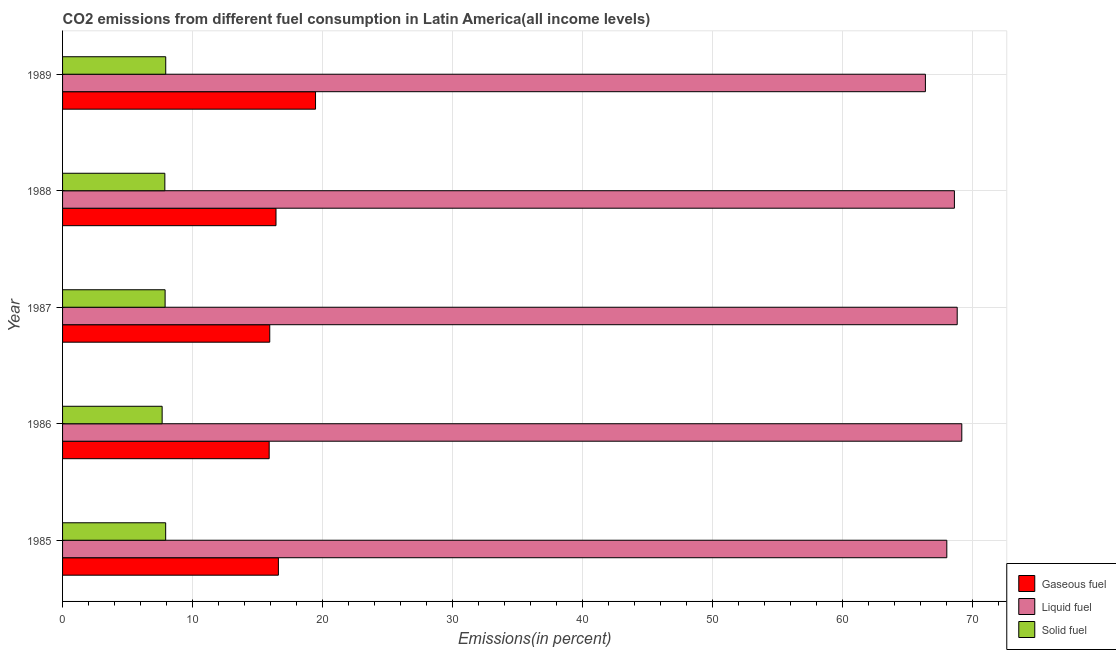How many different coloured bars are there?
Offer a very short reply. 3. Are the number of bars per tick equal to the number of legend labels?
Your response must be concise. Yes. How many bars are there on the 4th tick from the top?
Offer a very short reply. 3. How many bars are there on the 3rd tick from the bottom?
Offer a very short reply. 3. What is the percentage of gaseous fuel emission in 1985?
Your answer should be very brief. 16.6. Across all years, what is the maximum percentage of gaseous fuel emission?
Provide a succinct answer. 19.46. Across all years, what is the minimum percentage of gaseous fuel emission?
Keep it short and to the point. 15.89. In which year was the percentage of liquid fuel emission maximum?
Provide a succinct answer. 1986. In which year was the percentage of gaseous fuel emission minimum?
Make the answer very short. 1986. What is the total percentage of solid fuel emission in the graph?
Ensure brevity in your answer.  39.28. What is the difference between the percentage of solid fuel emission in 1986 and that in 1988?
Offer a very short reply. -0.21. What is the difference between the percentage of liquid fuel emission in 1986 and the percentage of gaseous fuel emission in 1988?
Keep it short and to the point. 52.75. What is the average percentage of solid fuel emission per year?
Provide a short and direct response. 7.86. In the year 1987, what is the difference between the percentage of gaseous fuel emission and percentage of solid fuel emission?
Give a very brief answer. 8.05. In how many years, is the percentage of gaseous fuel emission greater than 24 %?
Make the answer very short. 0. What is the difference between the highest and the second highest percentage of solid fuel emission?
Keep it short and to the point. 0.01. What is the difference between the highest and the lowest percentage of liquid fuel emission?
Your answer should be very brief. 2.8. In how many years, is the percentage of liquid fuel emission greater than the average percentage of liquid fuel emission taken over all years?
Your answer should be very brief. 3. Is the sum of the percentage of liquid fuel emission in 1987 and 1989 greater than the maximum percentage of gaseous fuel emission across all years?
Provide a succinct answer. Yes. What does the 1st bar from the top in 1989 represents?
Keep it short and to the point. Solid fuel. What does the 2nd bar from the bottom in 1988 represents?
Provide a short and direct response. Liquid fuel. Is it the case that in every year, the sum of the percentage of gaseous fuel emission and percentage of liquid fuel emission is greater than the percentage of solid fuel emission?
Make the answer very short. Yes. Are all the bars in the graph horizontal?
Offer a very short reply. Yes. How many years are there in the graph?
Offer a terse response. 5. What is the difference between two consecutive major ticks on the X-axis?
Provide a succinct answer. 10. Does the graph contain grids?
Provide a succinct answer. Yes. Where does the legend appear in the graph?
Your answer should be very brief. Bottom right. How many legend labels are there?
Your response must be concise. 3. How are the legend labels stacked?
Offer a terse response. Vertical. What is the title of the graph?
Ensure brevity in your answer.  CO2 emissions from different fuel consumption in Latin America(all income levels). What is the label or title of the X-axis?
Keep it short and to the point. Emissions(in percent). What is the Emissions(in percent) in Gaseous fuel in 1985?
Provide a short and direct response. 16.6. What is the Emissions(in percent) in Liquid fuel in 1985?
Your response must be concise. 68.02. What is the Emissions(in percent) in Solid fuel in 1985?
Your response must be concise. 7.93. What is the Emissions(in percent) in Gaseous fuel in 1986?
Offer a very short reply. 15.89. What is the Emissions(in percent) in Liquid fuel in 1986?
Ensure brevity in your answer.  69.17. What is the Emissions(in percent) of Solid fuel in 1986?
Offer a terse response. 7.66. What is the Emissions(in percent) in Gaseous fuel in 1987?
Offer a terse response. 15.94. What is the Emissions(in percent) of Liquid fuel in 1987?
Your answer should be very brief. 68.82. What is the Emissions(in percent) in Solid fuel in 1987?
Provide a short and direct response. 7.89. What is the Emissions(in percent) in Gaseous fuel in 1988?
Offer a very short reply. 16.42. What is the Emissions(in percent) of Liquid fuel in 1988?
Offer a terse response. 68.61. What is the Emissions(in percent) in Solid fuel in 1988?
Offer a terse response. 7.87. What is the Emissions(in percent) in Gaseous fuel in 1989?
Ensure brevity in your answer.  19.46. What is the Emissions(in percent) of Liquid fuel in 1989?
Offer a very short reply. 66.37. What is the Emissions(in percent) in Solid fuel in 1989?
Provide a succinct answer. 7.94. Across all years, what is the maximum Emissions(in percent) in Gaseous fuel?
Provide a succinct answer. 19.46. Across all years, what is the maximum Emissions(in percent) of Liquid fuel?
Make the answer very short. 69.17. Across all years, what is the maximum Emissions(in percent) in Solid fuel?
Provide a short and direct response. 7.94. Across all years, what is the minimum Emissions(in percent) of Gaseous fuel?
Offer a very short reply. 15.89. Across all years, what is the minimum Emissions(in percent) of Liquid fuel?
Provide a short and direct response. 66.37. Across all years, what is the minimum Emissions(in percent) in Solid fuel?
Your response must be concise. 7.66. What is the total Emissions(in percent) in Gaseous fuel in the graph?
Offer a terse response. 84.31. What is the total Emissions(in percent) in Liquid fuel in the graph?
Your answer should be compact. 341. What is the total Emissions(in percent) of Solid fuel in the graph?
Provide a succinct answer. 39.28. What is the difference between the Emissions(in percent) in Gaseous fuel in 1985 and that in 1986?
Offer a terse response. 0.71. What is the difference between the Emissions(in percent) of Liquid fuel in 1985 and that in 1986?
Offer a very short reply. -1.15. What is the difference between the Emissions(in percent) of Solid fuel in 1985 and that in 1986?
Your answer should be very brief. 0.27. What is the difference between the Emissions(in percent) in Gaseous fuel in 1985 and that in 1987?
Ensure brevity in your answer.  0.66. What is the difference between the Emissions(in percent) of Liquid fuel in 1985 and that in 1987?
Ensure brevity in your answer.  -0.8. What is the difference between the Emissions(in percent) of Solid fuel in 1985 and that in 1987?
Make the answer very short. 0.04. What is the difference between the Emissions(in percent) of Gaseous fuel in 1985 and that in 1988?
Offer a terse response. 0.18. What is the difference between the Emissions(in percent) in Liquid fuel in 1985 and that in 1988?
Offer a very short reply. -0.58. What is the difference between the Emissions(in percent) in Solid fuel in 1985 and that in 1988?
Give a very brief answer. 0.06. What is the difference between the Emissions(in percent) in Gaseous fuel in 1985 and that in 1989?
Your response must be concise. -2.86. What is the difference between the Emissions(in percent) in Liquid fuel in 1985 and that in 1989?
Ensure brevity in your answer.  1.65. What is the difference between the Emissions(in percent) of Solid fuel in 1985 and that in 1989?
Offer a very short reply. -0.01. What is the difference between the Emissions(in percent) in Gaseous fuel in 1986 and that in 1987?
Provide a succinct answer. -0.04. What is the difference between the Emissions(in percent) of Liquid fuel in 1986 and that in 1987?
Your answer should be compact. 0.35. What is the difference between the Emissions(in percent) of Solid fuel in 1986 and that in 1987?
Make the answer very short. -0.23. What is the difference between the Emissions(in percent) in Gaseous fuel in 1986 and that in 1988?
Provide a succinct answer. -0.52. What is the difference between the Emissions(in percent) in Liquid fuel in 1986 and that in 1988?
Your answer should be very brief. 0.57. What is the difference between the Emissions(in percent) of Solid fuel in 1986 and that in 1988?
Provide a short and direct response. -0.21. What is the difference between the Emissions(in percent) in Gaseous fuel in 1986 and that in 1989?
Give a very brief answer. -3.57. What is the difference between the Emissions(in percent) in Liquid fuel in 1986 and that in 1989?
Offer a very short reply. 2.8. What is the difference between the Emissions(in percent) of Solid fuel in 1986 and that in 1989?
Ensure brevity in your answer.  -0.28. What is the difference between the Emissions(in percent) in Gaseous fuel in 1987 and that in 1988?
Your answer should be very brief. -0.48. What is the difference between the Emissions(in percent) of Liquid fuel in 1987 and that in 1988?
Ensure brevity in your answer.  0.22. What is the difference between the Emissions(in percent) of Solid fuel in 1987 and that in 1988?
Give a very brief answer. 0.02. What is the difference between the Emissions(in percent) of Gaseous fuel in 1987 and that in 1989?
Your answer should be very brief. -3.52. What is the difference between the Emissions(in percent) of Liquid fuel in 1987 and that in 1989?
Keep it short and to the point. 2.45. What is the difference between the Emissions(in percent) in Solid fuel in 1987 and that in 1989?
Offer a very short reply. -0.05. What is the difference between the Emissions(in percent) of Gaseous fuel in 1988 and that in 1989?
Your answer should be very brief. -3.04. What is the difference between the Emissions(in percent) in Liquid fuel in 1988 and that in 1989?
Your response must be concise. 2.23. What is the difference between the Emissions(in percent) of Solid fuel in 1988 and that in 1989?
Offer a very short reply. -0.07. What is the difference between the Emissions(in percent) in Gaseous fuel in 1985 and the Emissions(in percent) in Liquid fuel in 1986?
Keep it short and to the point. -52.57. What is the difference between the Emissions(in percent) of Gaseous fuel in 1985 and the Emissions(in percent) of Solid fuel in 1986?
Provide a succinct answer. 8.94. What is the difference between the Emissions(in percent) of Liquid fuel in 1985 and the Emissions(in percent) of Solid fuel in 1986?
Provide a succinct answer. 60.36. What is the difference between the Emissions(in percent) of Gaseous fuel in 1985 and the Emissions(in percent) of Liquid fuel in 1987?
Your answer should be compact. -52.22. What is the difference between the Emissions(in percent) of Gaseous fuel in 1985 and the Emissions(in percent) of Solid fuel in 1987?
Keep it short and to the point. 8.71. What is the difference between the Emissions(in percent) of Liquid fuel in 1985 and the Emissions(in percent) of Solid fuel in 1987?
Your answer should be very brief. 60.13. What is the difference between the Emissions(in percent) of Gaseous fuel in 1985 and the Emissions(in percent) of Liquid fuel in 1988?
Provide a short and direct response. -52. What is the difference between the Emissions(in percent) of Gaseous fuel in 1985 and the Emissions(in percent) of Solid fuel in 1988?
Make the answer very short. 8.73. What is the difference between the Emissions(in percent) in Liquid fuel in 1985 and the Emissions(in percent) in Solid fuel in 1988?
Ensure brevity in your answer.  60.15. What is the difference between the Emissions(in percent) of Gaseous fuel in 1985 and the Emissions(in percent) of Liquid fuel in 1989?
Your response must be concise. -49.77. What is the difference between the Emissions(in percent) of Gaseous fuel in 1985 and the Emissions(in percent) of Solid fuel in 1989?
Your answer should be compact. 8.67. What is the difference between the Emissions(in percent) in Liquid fuel in 1985 and the Emissions(in percent) in Solid fuel in 1989?
Give a very brief answer. 60.09. What is the difference between the Emissions(in percent) in Gaseous fuel in 1986 and the Emissions(in percent) in Liquid fuel in 1987?
Provide a short and direct response. -52.93. What is the difference between the Emissions(in percent) of Gaseous fuel in 1986 and the Emissions(in percent) of Solid fuel in 1987?
Offer a terse response. 8.01. What is the difference between the Emissions(in percent) in Liquid fuel in 1986 and the Emissions(in percent) in Solid fuel in 1987?
Offer a terse response. 61.29. What is the difference between the Emissions(in percent) in Gaseous fuel in 1986 and the Emissions(in percent) in Liquid fuel in 1988?
Your answer should be compact. -52.71. What is the difference between the Emissions(in percent) in Gaseous fuel in 1986 and the Emissions(in percent) in Solid fuel in 1988?
Provide a succinct answer. 8.03. What is the difference between the Emissions(in percent) in Liquid fuel in 1986 and the Emissions(in percent) in Solid fuel in 1988?
Give a very brief answer. 61.31. What is the difference between the Emissions(in percent) in Gaseous fuel in 1986 and the Emissions(in percent) in Liquid fuel in 1989?
Make the answer very short. -50.48. What is the difference between the Emissions(in percent) of Gaseous fuel in 1986 and the Emissions(in percent) of Solid fuel in 1989?
Your response must be concise. 7.96. What is the difference between the Emissions(in percent) in Liquid fuel in 1986 and the Emissions(in percent) in Solid fuel in 1989?
Offer a terse response. 61.24. What is the difference between the Emissions(in percent) in Gaseous fuel in 1987 and the Emissions(in percent) in Liquid fuel in 1988?
Make the answer very short. -52.67. What is the difference between the Emissions(in percent) of Gaseous fuel in 1987 and the Emissions(in percent) of Solid fuel in 1988?
Your response must be concise. 8.07. What is the difference between the Emissions(in percent) of Liquid fuel in 1987 and the Emissions(in percent) of Solid fuel in 1988?
Your response must be concise. 60.95. What is the difference between the Emissions(in percent) in Gaseous fuel in 1987 and the Emissions(in percent) in Liquid fuel in 1989?
Keep it short and to the point. -50.44. What is the difference between the Emissions(in percent) in Gaseous fuel in 1987 and the Emissions(in percent) in Solid fuel in 1989?
Offer a very short reply. 8. What is the difference between the Emissions(in percent) of Liquid fuel in 1987 and the Emissions(in percent) of Solid fuel in 1989?
Keep it short and to the point. 60.88. What is the difference between the Emissions(in percent) in Gaseous fuel in 1988 and the Emissions(in percent) in Liquid fuel in 1989?
Your answer should be very brief. -49.96. What is the difference between the Emissions(in percent) of Gaseous fuel in 1988 and the Emissions(in percent) of Solid fuel in 1989?
Your answer should be compact. 8.48. What is the difference between the Emissions(in percent) in Liquid fuel in 1988 and the Emissions(in percent) in Solid fuel in 1989?
Provide a succinct answer. 60.67. What is the average Emissions(in percent) in Gaseous fuel per year?
Keep it short and to the point. 16.86. What is the average Emissions(in percent) in Liquid fuel per year?
Your answer should be compact. 68.2. What is the average Emissions(in percent) in Solid fuel per year?
Your response must be concise. 7.86. In the year 1985, what is the difference between the Emissions(in percent) in Gaseous fuel and Emissions(in percent) in Liquid fuel?
Make the answer very short. -51.42. In the year 1985, what is the difference between the Emissions(in percent) in Gaseous fuel and Emissions(in percent) in Solid fuel?
Offer a terse response. 8.67. In the year 1985, what is the difference between the Emissions(in percent) in Liquid fuel and Emissions(in percent) in Solid fuel?
Your answer should be compact. 60.09. In the year 1986, what is the difference between the Emissions(in percent) in Gaseous fuel and Emissions(in percent) in Liquid fuel?
Provide a succinct answer. -53.28. In the year 1986, what is the difference between the Emissions(in percent) of Gaseous fuel and Emissions(in percent) of Solid fuel?
Provide a short and direct response. 8.23. In the year 1986, what is the difference between the Emissions(in percent) of Liquid fuel and Emissions(in percent) of Solid fuel?
Provide a succinct answer. 61.51. In the year 1987, what is the difference between the Emissions(in percent) of Gaseous fuel and Emissions(in percent) of Liquid fuel?
Provide a short and direct response. -52.88. In the year 1987, what is the difference between the Emissions(in percent) in Gaseous fuel and Emissions(in percent) in Solid fuel?
Your answer should be very brief. 8.05. In the year 1987, what is the difference between the Emissions(in percent) of Liquid fuel and Emissions(in percent) of Solid fuel?
Make the answer very short. 60.93. In the year 1988, what is the difference between the Emissions(in percent) in Gaseous fuel and Emissions(in percent) in Liquid fuel?
Your answer should be very brief. -52.19. In the year 1988, what is the difference between the Emissions(in percent) in Gaseous fuel and Emissions(in percent) in Solid fuel?
Your response must be concise. 8.55. In the year 1988, what is the difference between the Emissions(in percent) of Liquid fuel and Emissions(in percent) of Solid fuel?
Offer a terse response. 60.74. In the year 1989, what is the difference between the Emissions(in percent) of Gaseous fuel and Emissions(in percent) of Liquid fuel?
Your answer should be compact. -46.92. In the year 1989, what is the difference between the Emissions(in percent) of Gaseous fuel and Emissions(in percent) of Solid fuel?
Your answer should be compact. 11.52. In the year 1989, what is the difference between the Emissions(in percent) of Liquid fuel and Emissions(in percent) of Solid fuel?
Offer a very short reply. 58.44. What is the ratio of the Emissions(in percent) in Gaseous fuel in 1985 to that in 1986?
Your response must be concise. 1.04. What is the ratio of the Emissions(in percent) of Liquid fuel in 1985 to that in 1986?
Your answer should be very brief. 0.98. What is the ratio of the Emissions(in percent) in Solid fuel in 1985 to that in 1986?
Make the answer very short. 1.04. What is the ratio of the Emissions(in percent) of Gaseous fuel in 1985 to that in 1987?
Ensure brevity in your answer.  1.04. What is the ratio of the Emissions(in percent) in Liquid fuel in 1985 to that in 1987?
Provide a succinct answer. 0.99. What is the ratio of the Emissions(in percent) of Gaseous fuel in 1985 to that in 1988?
Your response must be concise. 1.01. What is the ratio of the Emissions(in percent) of Gaseous fuel in 1985 to that in 1989?
Ensure brevity in your answer.  0.85. What is the ratio of the Emissions(in percent) in Liquid fuel in 1985 to that in 1989?
Make the answer very short. 1.02. What is the ratio of the Emissions(in percent) of Gaseous fuel in 1986 to that in 1987?
Keep it short and to the point. 1. What is the ratio of the Emissions(in percent) in Liquid fuel in 1986 to that in 1987?
Give a very brief answer. 1.01. What is the ratio of the Emissions(in percent) in Solid fuel in 1986 to that in 1987?
Offer a very short reply. 0.97. What is the ratio of the Emissions(in percent) in Liquid fuel in 1986 to that in 1988?
Ensure brevity in your answer.  1.01. What is the ratio of the Emissions(in percent) in Solid fuel in 1986 to that in 1988?
Ensure brevity in your answer.  0.97. What is the ratio of the Emissions(in percent) of Gaseous fuel in 1986 to that in 1989?
Provide a short and direct response. 0.82. What is the ratio of the Emissions(in percent) in Liquid fuel in 1986 to that in 1989?
Provide a short and direct response. 1.04. What is the ratio of the Emissions(in percent) of Solid fuel in 1986 to that in 1989?
Ensure brevity in your answer.  0.97. What is the ratio of the Emissions(in percent) of Gaseous fuel in 1987 to that in 1988?
Provide a succinct answer. 0.97. What is the ratio of the Emissions(in percent) of Gaseous fuel in 1987 to that in 1989?
Give a very brief answer. 0.82. What is the ratio of the Emissions(in percent) in Liquid fuel in 1987 to that in 1989?
Give a very brief answer. 1.04. What is the ratio of the Emissions(in percent) of Gaseous fuel in 1988 to that in 1989?
Keep it short and to the point. 0.84. What is the ratio of the Emissions(in percent) in Liquid fuel in 1988 to that in 1989?
Give a very brief answer. 1.03. What is the difference between the highest and the second highest Emissions(in percent) of Gaseous fuel?
Provide a succinct answer. 2.86. What is the difference between the highest and the second highest Emissions(in percent) in Liquid fuel?
Ensure brevity in your answer.  0.35. What is the difference between the highest and the second highest Emissions(in percent) of Solid fuel?
Make the answer very short. 0.01. What is the difference between the highest and the lowest Emissions(in percent) in Gaseous fuel?
Offer a terse response. 3.57. What is the difference between the highest and the lowest Emissions(in percent) of Liquid fuel?
Your answer should be compact. 2.8. What is the difference between the highest and the lowest Emissions(in percent) of Solid fuel?
Make the answer very short. 0.28. 